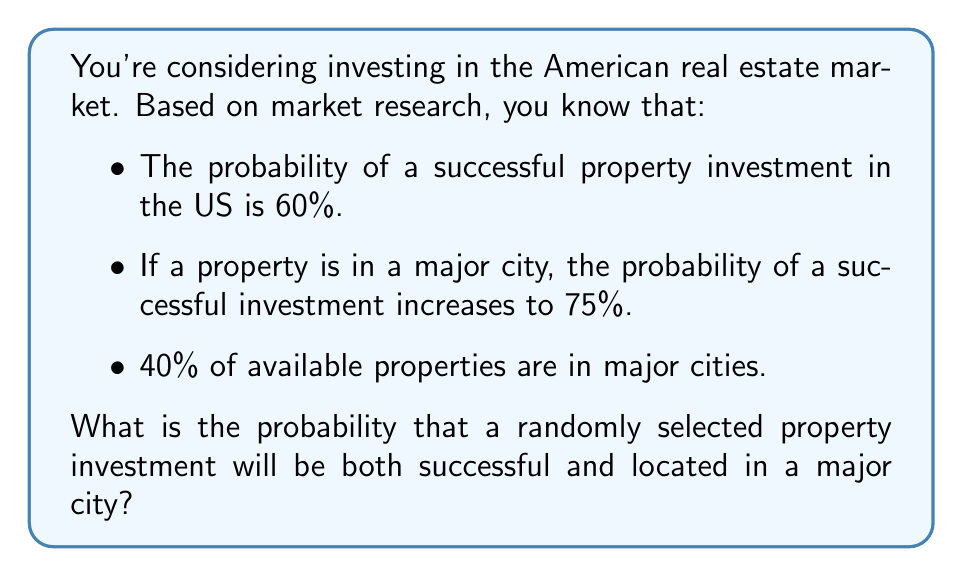Could you help me with this problem? Let's approach this step-by-step using conditional probability:

1) Let's define our events:
   S: Successful investment
   M: Property is in a major city

2) We're given the following probabilities:
   $P(S) = 0.60$ (overall probability of success)
   $P(S|M) = 0.75$ (probability of success given it's in a major city)
   $P(M) = 0.40$ (probability of being in a major city)

3) We want to find $P(S \cap M)$, which is the probability of both S and M occurring.

4) We can use the multiplication rule of probability:
   $P(S \cap M) = P(M) \cdot P(S|M)$

5) Substituting the values:
   $P(S \cap M) = 0.40 \cdot 0.75 = 0.30$

Therefore, the probability that a randomly selected property investment will be both successful and located in a major city is 0.30 or 30%.

Note: This can be verified using Bayes' theorem:
$P(S \cap M) = P(M) \cdot P(S|M) = P(S) \cdot P(M|S)$

We could calculate $P(M|S)$ using:
$P(M|S) = \frac{P(S|M) \cdot P(M)}{P(S)} = \frac{0.75 \cdot 0.40}{0.60} = 0.50$

Then:
$P(S \cap M) = 0.60 \cdot 0.50 = 0.30$

This confirms our initial calculation.
Answer: 0.30 or 30% 